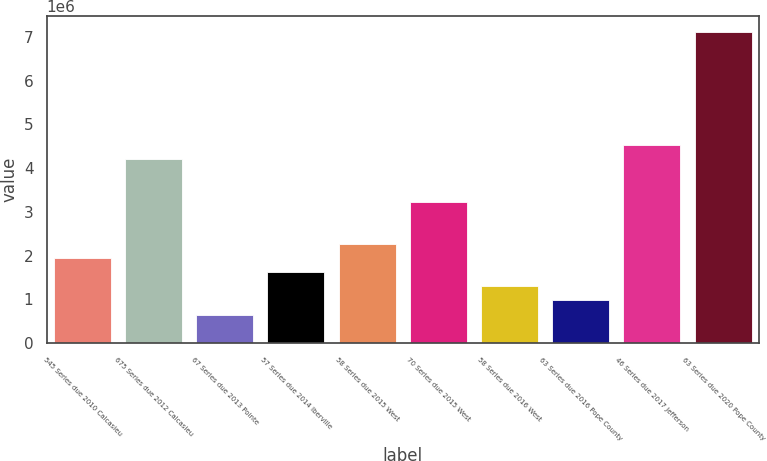Convert chart. <chart><loc_0><loc_0><loc_500><loc_500><bar_chart><fcel>545 Series due 2010 Calcasieu<fcel>675 Series due 2012 Calcasieu<fcel>67 Series due 2013 Pointe<fcel>57 Series due 2014 Iberville<fcel>58 Series due 2015 West<fcel>70 Series due 2015 West<fcel>58 Series due 2016 West<fcel>63 Series due 2016 Pope County<fcel>46 Series due 2017 Jefferson<fcel>63 Series due 2020 Pope County<nl><fcel>1.94522e+06<fcel>4.20659e+06<fcel>653012<fcel>1.62217e+06<fcel>2.26828e+06<fcel>3.23743e+06<fcel>1.29912e+06<fcel>976064<fcel>4.52965e+06<fcel>7.11407e+06<nl></chart> 